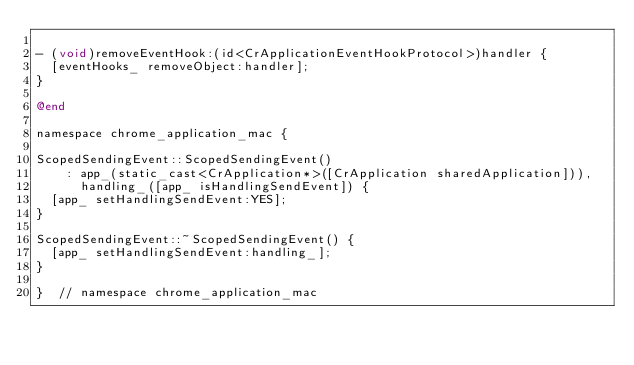Convert code to text. <code><loc_0><loc_0><loc_500><loc_500><_ObjectiveC_>
- (void)removeEventHook:(id<CrApplicationEventHookProtocol>)handler {
  [eventHooks_ removeObject:handler];
}

@end

namespace chrome_application_mac {

ScopedSendingEvent::ScopedSendingEvent()
    : app_(static_cast<CrApplication*>([CrApplication sharedApplication])),
      handling_([app_ isHandlingSendEvent]) {
  [app_ setHandlingSendEvent:YES];
}

ScopedSendingEvent::~ScopedSendingEvent() {
  [app_ setHandlingSendEvent:handling_];
}

}  // namespace chrome_application_mac
</code> 